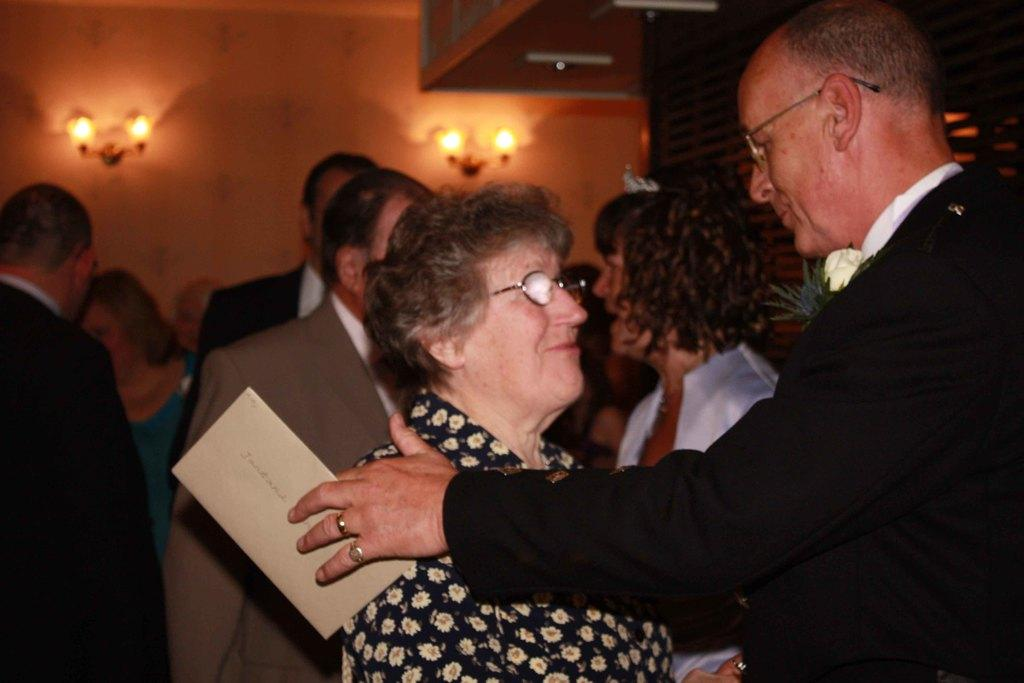How many people are in the image? There is a group of persons in the image. What is the person in the foreground holding? The person in the foreground is holding an object. What can be seen behind the persons in the image? There is a wall visible behind the persons. What is attached to the wall in the image? Lights are present on the wall. What type of soup is being cooked by the person in the image? There is no person cooking soup in the image, nor is there any soup present. 